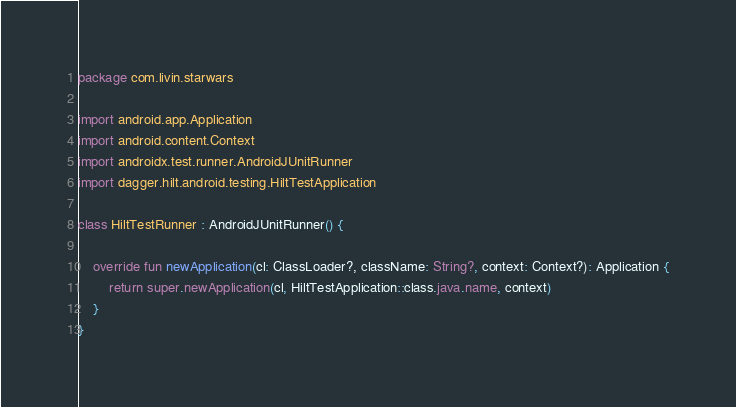Convert code to text. <code><loc_0><loc_0><loc_500><loc_500><_Kotlin_>package com.livin.starwars

import android.app.Application
import android.content.Context
import androidx.test.runner.AndroidJUnitRunner
import dagger.hilt.android.testing.HiltTestApplication

class HiltTestRunner : AndroidJUnitRunner() {

    override fun newApplication(cl: ClassLoader?, className: String?, context: Context?): Application {
        return super.newApplication(cl, HiltTestApplication::class.java.name, context)
    }
}</code> 